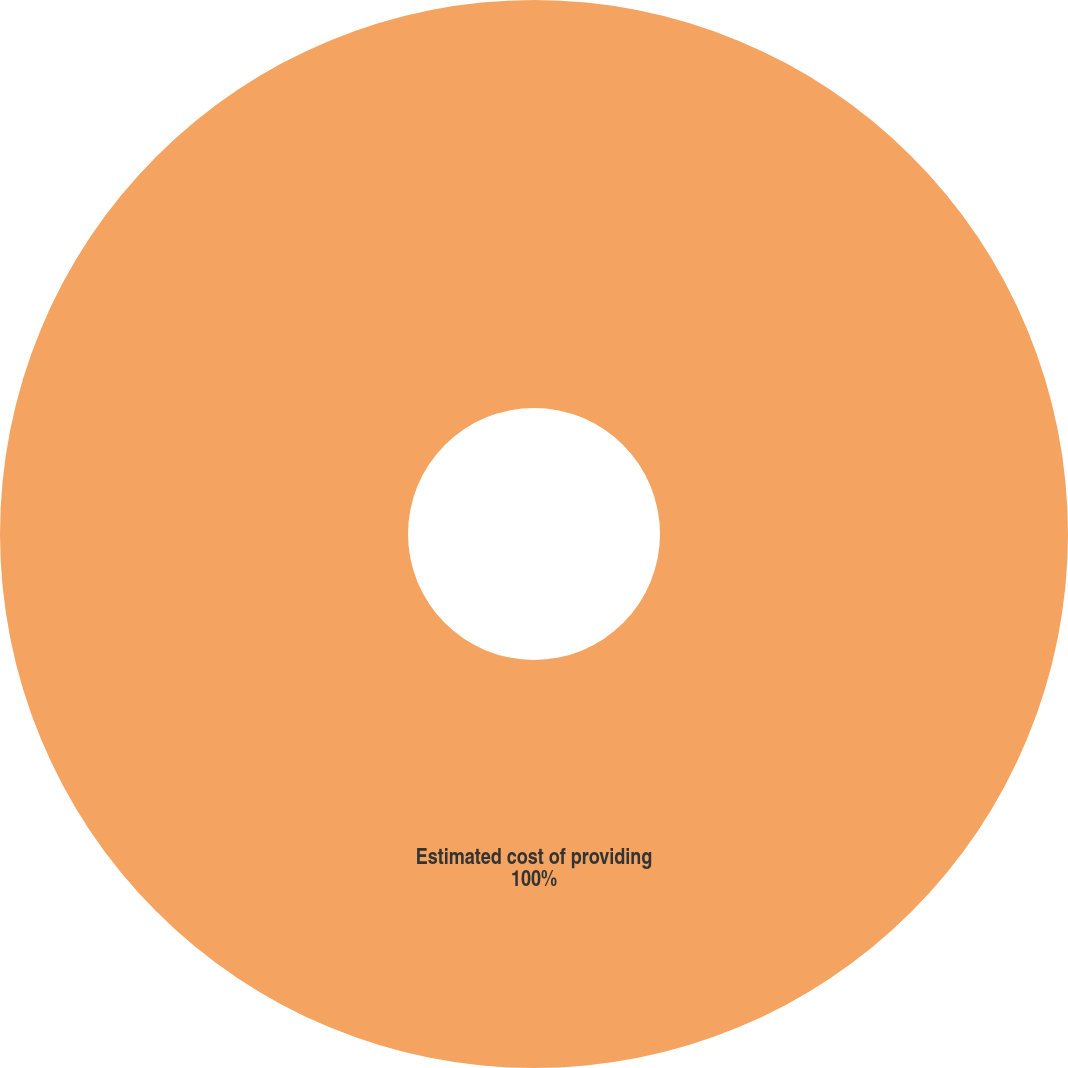Convert chart. <chart><loc_0><loc_0><loc_500><loc_500><pie_chart><fcel>Estimated cost of providing<nl><fcel>100.0%<nl></chart> 